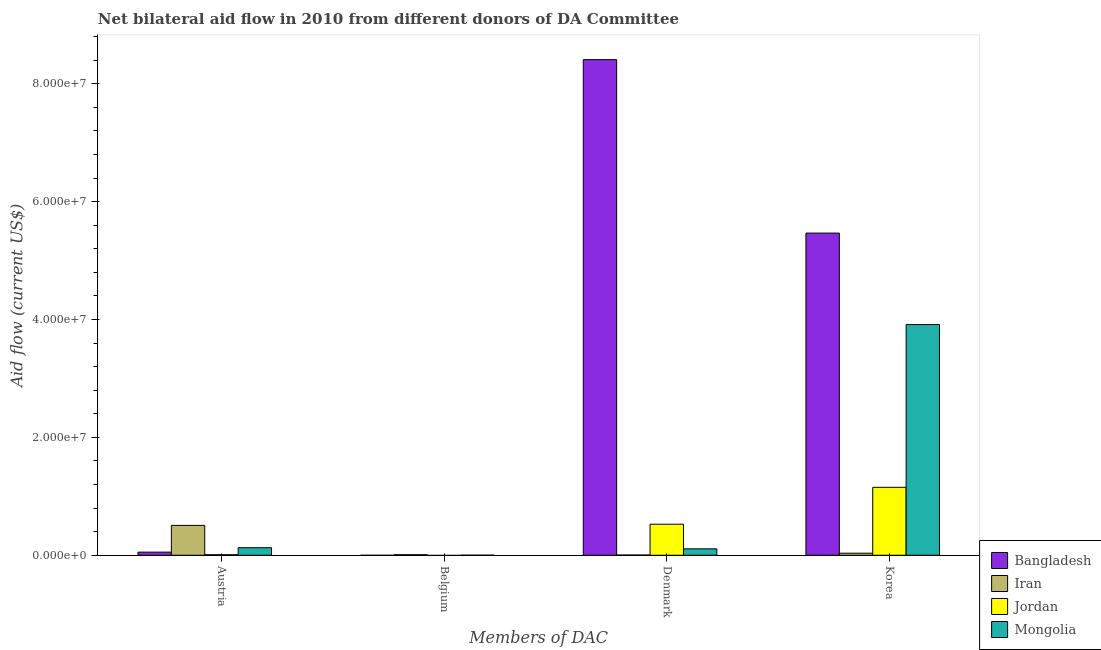Are the number of bars per tick equal to the number of legend labels?
Offer a very short reply. No. Are the number of bars on each tick of the X-axis equal?
Make the answer very short. No. What is the label of the 3rd group of bars from the left?
Your response must be concise. Denmark. What is the amount of aid given by denmark in Iran?
Keep it short and to the point. 4.00e+04. Across all countries, what is the maximum amount of aid given by korea?
Ensure brevity in your answer.  5.47e+07. What is the total amount of aid given by austria in the graph?
Your answer should be compact. 6.97e+06. What is the difference between the amount of aid given by denmark in Mongolia and that in Bangladesh?
Ensure brevity in your answer.  -8.30e+07. What is the difference between the amount of aid given by austria in Mongolia and the amount of aid given by denmark in Bangladesh?
Provide a succinct answer. -8.28e+07. What is the average amount of aid given by korea per country?
Your response must be concise. 2.64e+07. What is the difference between the amount of aid given by denmark and amount of aid given by korea in Iran?
Give a very brief answer. -3.10e+05. What is the ratio of the amount of aid given by korea in Iran to that in Bangladesh?
Ensure brevity in your answer.  0.01. What is the difference between the highest and the second highest amount of aid given by korea?
Keep it short and to the point. 1.55e+07. What is the difference between the highest and the lowest amount of aid given by korea?
Provide a succinct answer. 5.43e+07. In how many countries, is the amount of aid given by belgium greater than the average amount of aid given by belgium taken over all countries?
Your response must be concise. 1. Is the sum of the amount of aid given by korea in Jordan and Mongolia greater than the maximum amount of aid given by belgium across all countries?
Offer a terse response. Yes. Is it the case that in every country, the sum of the amount of aid given by austria and amount of aid given by belgium is greater than the amount of aid given by denmark?
Your answer should be very brief. No. How many bars are there?
Ensure brevity in your answer.  14. Are all the bars in the graph horizontal?
Keep it short and to the point. No. Are the values on the major ticks of Y-axis written in scientific E-notation?
Give a very brief answer. Yes. Does the graph contain grids?
Your answer should be compact. No. Where does the legend appear in the graph?
Ensure brevity in your answer.  Bottom right. How many legend labels are there?
Offer a terse response. 4. How are the legend labels stacked?
Keep it short and to the point. Vertical. What is the title of the graph?
Make the answer very short. Net bilateral aid flow in 2010 from different donors of DA Committee. Does "Swaziland" appear as one of the legend labels in the graph?
Offer a very short reply. No. What is the label or title of the X-axis?
Ensure brevity in your answer.  Members of DAC. What is the label or title of the Y-axis?
Keep it short and to the point. Aid flow (current US$). What is the Aid flow (current US$) in Bangladesh in Austria?
Offer a very short reply. 5.30e+05. What is the Aid flow (current US$) of Iran in Austria?
Make the answer very short. 5.07e+06. What is the Aid flow (current US$) in Jordan in Austria?
Make the answer very short. 9.00e+04. What is the Aid flow (current US$) of Mongolia in Austria?
Ensure brevity in your answer.  1.28e+06. What is the Aid flow (current US$) in Iran in Belgium?
Offer a very short reply. 9.00e+04. What is the Aid flow (current US$) of Jordan in Belgium?
Your answer should be very brief. 0. What is the Aid flow (current US$) in Bangladesh in Denmark?
Your response must be concise. 8.41e+07. What is the Aid flow (current US$) of Iran in Denmark?
Offer a very short reply. 4.00e+04. What is the Aid flow (current US$) in Jordan in Denmark?
Your answer should be very brief. 5.27e+06. What is the Aid flow (current US$) in Mongolia in Denmark?
Make the answer very short. 1.09e+06. What is the Aid flow (current US$) of Bangladesh in Korea?
Ensure brevity in your answer.  5.47e+07. What is the Aid flow (current US$) in Iran in Korea?
Give a very brief answer. 3.50e+05. What is the Aid flow (current US$) in Jordan in Korea?
Offer a very short reply. 1.15e+07. What is the Aid flow (current US$) of Mongolia in Korea?
Provide a short and direct response. 3.92e+07. Across all Members of DAC, what is the maximum Aid flow (current US$) in Bangladesh?
Your answer should be very brief. 8.41e+07. Across all Members of DAC, what is the maximum Aid flow (current US$) of Iran?
Offer a very short reply. 5.07e+06. Across all Members of DAC, what is the maximum Aid flow (current US$) of Jordan?
Provide a succinct answer. 1.15e+07. Across all Members of DAC, what is the maximum Aid flow (current US$) in Mongolia?
Your answer should be very brief. 3.92e+07. Across all Members of DAC, what is the minimum Aid flow (current US$) in Bangladesh?
Make the answer very short. 0. Across all Members of DAC, what is the minimum Aid flow (current US$) of Jordan?
Offer a very short reply. 0. What is the total Aid flow (current US$) in Bangladesh in the graph?
Your answer should be compact. 1.39e+08. What is the total Aid flow (current US$) of Iran in the graph?
Offer a terse response. 5.55e+06. What is the total Aid flow (current US$) in Jordan in the graph?
Your answer should be very brief. 1.69e+07. What is the total Aid flow (current US$) in Mongolia in the graph?
Your answer should be compact. 4.15e+07. What is the difference between the Aid flow (current US$) in Iran in Austria and that in Belgium?
Give a very brief answer. 4.98e+06. What is the difference between the Aid flow (current US$) of Mongolia in Austria and that in Belgium?
Offer a very short reply. 1.27e+06. What is the difference between the Aid flow (current US$) of Bangladesh in Austria and that in Denmark?
Give a very brief answer. -8.36e+07. What is the difference between the Aid flow (current US$) of Iran in Austria and that in Denmark?
Your answer should be very brief. 5.03e+06. What is the difference between the Aid flow (current US$) of Jordan in Austria and that in Denmark?
Your answer should be very brief. -5.18e+06. What is the difference between the Aid flow (current US$) of Bangladesh in Austria and that in Korea?
Offer a very short reply. -5.41e+07. What is the difference between the Aid flow (current US$) of Iran in Austria and that in Korea?
Give a very brief answer. 4.72e+06. What is the difference between the Aid flow (current US$) in Jordan in Austria and that in Korea?
Provide a short and direct response. -1.14e+07. What is the difference between the Aid flow (current US$) in Mongolia in Austria and that in Korea?
Provide a succinct answer. -3.79e+07. What is the difference between the Aid flow (current US$) in Mongolia in Belgium and that in Denmark?
Offer a very short reply. -1.08e+06. What is the difference between the Aid flow (current US$) of Mongolia in Belgium and that in Korea?
Keep it short and to the point. -3.91e+07. What is the difference between the Aid flow (current US$) in Bangladesh in Denmark and that in Korea?
Offer a terse response. 2.94e+07. What is the difference between the Aid flow (current US$) of Iran in Denmark and that in Korea?
Provide a succinct answer. -3.10e+05. What is the difference between the Aid flow (current US$) in Jordan in Denmark and that in Korea?
Give a very brief answer. -6.26e+06. What is the difference between the Aid flow (current US$) of Mongolia in Denmark and that in Korea?
Make the answer very short. -3.81e+07. What is the difference between the Aid flow (current US$) of Bangladesh in Austria and the Aid flow (current US$) of Iran in Belgium?
Your answer should be compact. 4.40e+05. What is the difference between the Aid flow (current US$) of Bangladesh in Austria and the Aid flow (current US$) of Mongolia in Belgium?
Offer a very short reply. 5.20e+05. What is the difference between the Aid flow (current US$) in Iran in Austria and the Aid flow (current US$) in Mongolia in Belgium?
Your answer should be very brief. 5.06e+06. What is the difference between the Aid flow (current US$) in Bangladesh in Austria and the Aid flow (current US$) in Jordan in Denmark?
Provide a short and direct response. -4.74e+06. What is the difference between the Aid flow (current US$) in Bangladesh in Austria and the Aid flow (current US$) in Mongolia in Denmark?
Offer a terse response. -5.60e+05. What is the difference between the Aid flow (current US$) in Iran in Austria and the Aid flow (current US$) in Jordan in Denmark?
Your response must be concise. -2.00e+05. What is the difference between the Aid flow (current US$) of Iran in Austria and the Aid flow (current US$) of Mongolia in Denmark?
Keep it short and to the point. 3.98e+06. What is the difference between the Aid flow (current US$) of Bangladesh in Austria and the Aid flow (current US$) of Iran in Korea?
Offer a very short reply. 1.80e+05. What is the difference between the Aid flow (current US$) of Bangladesh in Austria and the Aid flow (current US$) of Jordan in Korea?
Make the answer very short. -1.10e+07. What is the difference between the Aid flow (current US$) of Bangladesh in Austria and the Aid flow (current US$) of Mongolia in Korea?
Keep it short and to the point. -3.86e+07. What is the difference between the Aid flow (current US$) in Iran in Austria and the Aid flow (current US$) in Jordan in Korea?
Ensure brevity in your answer.  -6.46e+06. What is the difference between the Aid flow (current US$) in Iran in Austria and the Aid flow (current US$) in Mongolia in Korea?
Your answer should be very brief. -3.41e+07. What is the difference between the Aid flow (current US$) in Jordan in Austria and the Aid flow (current US$) in Mongolia in Korea?
Your answer should be very brief. -3.91e+07. What is the difference between the Aid flow (current US$) in Iran in Belgium and the Aid flow (current US$) in Jordan in Denmark?
Ensure brevity in your answer.  -5.18e+06. What is the difference between the Aid flow (current US$) of Iran in Belgium and the Aid flow (current US$) of Jordan in Korea?
Give a very brief answer. -1.14e+07. What is the difference between the Aid flow (current US$) in Iran in Belgium and the Aid flow (current US$) in Mongolia in Korea?
Ensure brevity in your answer.  -3.91e+07. What is the difference between the Aid flow (current US$) in Bangladesh in Denmark and the Aid flow (current US$) in Iran in Korea?
Provide a short and direct response. 8.38e+07. What is the difference between the Aid flow (current US$) in Bangladesh in Denmark and the Aid flow (current US$) in Jordan in Korea?
Offer a terse response. 7.26e+07. What is the difference between the Aid flow (current US$) in Bangladesh in Denmark and the Aid flow (current US$) in Mongolia in Korea?
Ensure brevity in your answer.  4.50e+07. What is the difference between the Aid flow (current US$) in Iran in Denmark and the Aid flow (current US$) in Jordan in Korea?
Your response must be concise. -1.15e+07. What is the difference between the Aid flow (current US$) in Iran in Denmark and the Aid flow (current US$) in Mongolia in Korea?
Offer a very short reply. -3.91e+07. What is the difference between the Aid flow (current US$) of Jordan in Denmark and the Aid flow (current US$) of Mongolia in Korea?
Your answer should be very brief. -3.39e+07. What is the average Aid flow (current US$) in Bangladesh per Members of DAC?
Offer a very short reply. 3.48e+07. What is the average Aid flow (current US$) in Iran per Members of DAC?
Your answer should be compact. 1.39e+06. What is the average Aid flow (current US$) in Jordan per Members of DAC?
Offer a very short reply. 4.22e+06. What is the average Aid flow (current US$) in Mongolia per Members of DAC?
Make the answer very short. 1.04e+07. What is the difference between the Aid flow (current US$) of Bangladesh and Aid flow (current US$) of Iran in Austria?
Keep it short and to the point. -4.54e+06. What is the difference between the Aid flow (current US$) in Bangladesh and Aid flow (current US$) in Jordan in Austria?
Your answer should be very brief. 4.40e+05. What is the difference between the Aid flow (current US$) in Bangladesh and Aid flow (current US$) in Mongolia in Austria?
Keep it short and to the point. -7.50e+05. What is the difference between the Aid flow (current US$) in Iran and Aid flow (current US$) in Jordan in Austria?
Provide a succinct answer. 4.98e+06. What is the difference between the Aid flow (current US$) of Iran and Aid flow (current US$) of Mongolia in Austria?
Provide a succinct answer. 3.79e+06. What is the difference between the Aid flow (current US$) in Jordan and Aid flow (current US$) in Mongolia in Austria?
Ensure brevity in your answer.  -1.19e+06. What is the difference between the Aid flow (current US$) of Iran and Aid flow (current US$) of Mongolia in Belgium?
Provide a short and direct response. 8.00e+04. What is the difference between the Aid flow (current US$) of Bangladesh and Aid flow (current US$) of Iran in Denmark?
Offer a terse response. 8.41e+07. What is the difference between the Aid flow (current US$) of Bangladesh and Aid flow (current US$) of Jordan in Denmark?
Keep it short and to the point. 7.88e+07. What is the difference between the Aid flow (current US$) in Bangladesh and Aid flow (current US$) in Mongolia in Denmark?
Ensure brevity in your answer.  8.30e+07. What is the difference between the Aid flow (current US$) in Iran and Aid flow (current US$) in Jordan in Denmark?
Provide a succinct answer. -5.23e+06. What is the difference between the Aid flow (current US$) of Iran and Aid flow (current US$) of Mongolia in Denmark?
Offer a very short reply. -1.05e+06. What is the difference between the Aid flow (current US$) of Jordan and Aid flow (current US$) of Mongolia in Denmark?
Provide a succinct answer. 4.18e+06. What is the difference between the Aid flow (current US$) in Bangladesh and Aid flow (current US$) in Iran in Korea?
Ensure brevity in your answer.  5.43e+07. What is the difference between the Aid flow (current US$) of Bangladesh and Aid flow (current US$) of Jordan in Korea?
Keep it short and to the point. 4.31e+07. What is the difference between the Aid flow (current US$) of Bangladesh and Aid flow (current US$) of Mongolia in Korea?
Provide a succinct answer. 1.55e+07. What is the difference between the Aid flow (current US$) of Iran and Aid flow (current US$) of Jordan in Korea?
Offer a terse response. -1.12e+07. What is the difference between the Aid flow (current US$) of Iran and Aid flow (current US$) of Mongolia in Korea?
Provide a succinct answer. -3.88e+07. What is the difference between the Aid flow (current US$) of Jordan and Aid flow (current US$) of Mongolia in Korea?
Offer a very short reply. -2.76e+07. What is the ratio of the Aid flow (current US$) in Iran in Austria to that in Belgium?
Make the answer very short. 56.33. What is the ratio of the Aid flow (current US$) of Mongolia in Austria to that in Belgium?
Make the answer very short. 128. What is the ratio of the Aid flow (current US$) in Bangladesh in Austria to that in Denmark?
Your answer should be very brief. 0.01. What is the ratio of the Aid flow (current US$) in Iran in Austria to that in Denmark?
Keep it short and to the point. 126.75. What is the ratio of the Aid flow (current US$) of Jordan in Austria to that in Denmark?
Provide a succinct answer. 0.02. What is the ratio of the Aid flow (current US$) in Mongolia in Austria to that in Denmark?
Make the answer very short. 1.17. What is the ratio of the Aid flow (current US$) of Bangladesh in Austria to that in Korea?
Provide a succinct answer. 0.01. What is the ratio of the Aid flow (current US$) in Iran in Austria to that in Korea?
Provide a succinct answer. 14.49. What is the ratio of the Aid flow (current US$) of Jordan in Austria to that in Korea?
Offer a very short reply. 0.01. What is the ratio of the Aid flow (current US$) of Mongolia in Austria to that in Korea?
Your response must be concise. 0.03. What is the ratio of the Aid flow (current US$) in Iran in Belgium to that in Denmark?
Your answer should be very brief. 2.25. What is the ratio of the Aid flow (current US$) of Mongolia in Belgium to that in Denmark?
Keep it short and to the point. 0.01. What is the ratio of the Aid flow (current US$) of Iran in Belgium to that in Korea?
Your answer should be compact. 0.26. What is the ratio of the Aid flow (current US$) of Bangladesh in Denmark to that in Korea?
Ensure brevity in your answer.  1.54. What is the ratio of the Aid flow (current US$) in Iran in Denmark to that in Korea?
Ensure brevity in your answer.  0.11. What is the ratio of the Aid flow (current US$) of Jordan in Denmark to that in Korea?
Offer a terse response. 0.46. What is the ratio of the Aid flow (current US$) in Mongolia in Denmark to that in Korea?
Your response must be concise. 0.03. What is the difference between the highest and the second highest Aid flow (current US$) in Bangladesh?
Keep it short and to the point. 2.94e+07. What is the difference between the highest and the second highest Aid flow (current US$) in Iran?
Provide a short and direct response. 4.72e+06. What is the difference between the highest and the second highest Aid flow (current US$) in Jordan?
Provide a succinct answer. 6.26e+06. What is the difference between the highest and the second highest Aid flow (current US$) of Mongolia?
Your response must be concise. 3.79e+07. What is the difference between the highest and the lowest Aid flow (current US$) of Bangladesh?
Offer a very short reply. 8.41e+07. What is the difference between the highest and the lowest Aid flow (current US$) in Iran?
Offer a very short reply. 5.03e+06. What is the difference between the highest and the lowest Aid flow (current US$) in Jordan?
Offer a terse response. 1.15e+07. What is the difference between the highest and the lowest Aid flow (current US$) in Mongolia?
Give a very brief answer. 3.91e+07. 